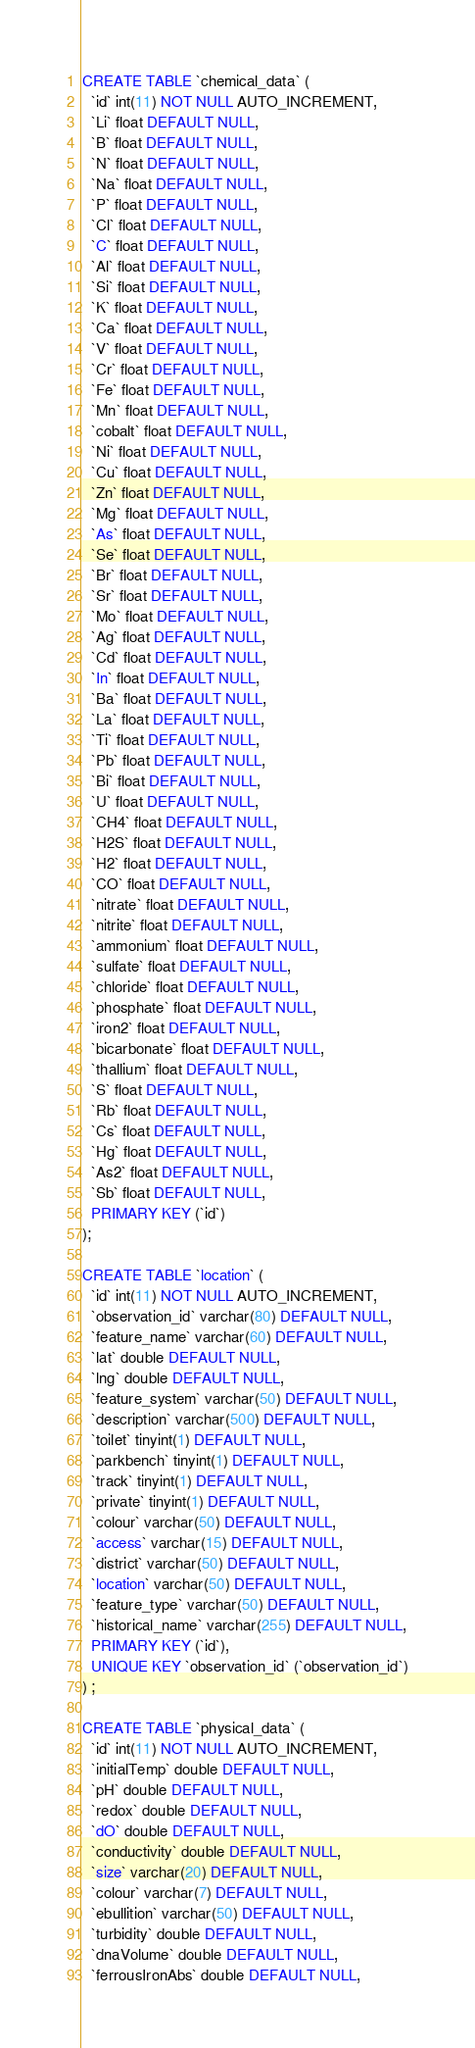Convert code to text. <code><loc_0><loc_0><loc_500><loc_500><_SQL_>CREATE TABLE `chemical_data` (
  `id` int(11) NOT NULL AUTO_INCREMENT,
  `Li` float DEFAULT NULL,
  `B` float DEFAULT NULL,
  `N` float DEFAULT NULL,
  `Na` float DEFAULT NULL,
  `P` float DEFAULT NULL,
  `Cl` float DEFAULT NULL,
  `C` float DEFAULT NULL,
  `Al` float DEFAULT NULL,
  `Si` float DEFAULT NULL,
  `K` float DEFAULT NULL,
  `Ca` float DEFAULT NULL,
  `V` float DEFAULT NULL,
  `Cr` float DEFAULT NULL,
  `Fe` float DEFAULT NULL,
  `Mn` float DEFAULT NULL,
  `cobalt` float DEFAULT NULL,
  `Ni` float DEFAULT NULL,
  `Cu` float DEFAULT NULL,
  `Zn` float DEFAULT NULL,
  `Mg` float DEFAULT NULL,
  `As` float DEFAULT NULL,
  `Se` float DEFAULT NULL,
  `Br` float DEFAULT NULL,
  `Sr` float DEFAULT NULL,
  `Mo` float DEFAULT NULL,
  `Ag` float DEFAULT NULL,
  `Cd` float DEFAULT NULL,
  `In` float DEFAULT NULL,
  `Ba` float DEFAULT NULL,
  `La` float DEFAULT NULL,
  `Ti` float DEFAULT NULL,
  `Pb` float DEFAULT NULL,
  `Bi` float DEFAULT NULL,
  `U` float DEFAULT NULL,
  `CH4` float DEFAULT NULL,
  `H2S` float DEFAULT NULL,
  `H2` float DEFAULT NULL,
  `CO` float DEFAULT NULL,
  `nitrate` float DEFAULT NULL,
  `nitrite` float DEFAULT NULL,
  `ammonium` float DEFAULT NULL,
  `sulfate` float DEFAULT NULL,
  `chloride` float DEFAULT NULL,
  `phosphate` float DEFAULT NULL,
  `iron2` float DEFAULT NULL,
  `bicarbonate` float DEFAULT NULL,
  `thallium` float DEFAULT NULL,
  `S` float DEFAULT NULL,
  `Rb` float DEFAULT NULL,
  `Cs` float DEFAULT NULL,
  `Hg` float DEFAULT NULL,
  `As2` float DEFAULT NULL,
  `Sb` float DEFAULT NULL,
  PRIMARY KEY (`id`)
);

CREATE TABLE `location` (
  `id` int(11) NOT NULL AUTO_INCREMENT,
  `observation_id` varchar(80) DEFAULT NULL,
  `feature_name` varchar(60) DEFAULT NULL,
  `lat` double DEFAULT NULL,
  `lng` double DEFAULT NULL,
  `feature_system` varchar(50) DEFAULT NULL,
  `description` varchar(500) DEFAULT NULL,
  `toilet` tinyint(1) DEFAULT NULL,
  `parkbench` tinyint(1) DEFAULT NULL,
  `track` tinyint(1) DEFAULT NULL,
  `private` tinyint(1) DEFAULT NULL,
  `colour` varchar(50) DEFAULT NULL,
  `access` varchar(15) DEFAULT NULL,
  `district` varchar(50) DEFAULT NULL,
  `location` varchar(50) DEFAULT NULL,
  `feature_type` varchar(50) DEFAULT NULL,
  `historical_name` varchar(255) DEFAULT NULL,
  PRIMARY KEY (`id`),
  UNIQUE KEY `observation_id` (`observation_id`)
) ;

CREATE TABLE `physical_data` (
  `id` int(11) NOT NULL AUTO_INCREMENT,
  `initialTemp` double DEFAULT NULL,
  `pH` double DEFAULT NULL,
  `redox` double DEFAULT NULL,
  `dO` double DEFAULT NULL,
  `conductivity` double DEFAULT NULL,
  `size` varchar(20) DEFAULT NULL,
  `colour` varchar(7) DEFAULT NULL,
  `ebullition` varchar(50) DEFAULT NULL,
  `turbidity` double DEFAULT NULL,
  `dnaVolume` double DEFAULT NULL,
  `ferrousIronAbs` double DEFAULT NULL,</code> 